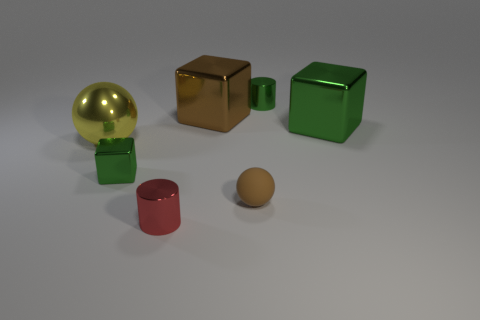Add 3 small green things. How many objects exist? 10 Subtract all spheres. How many objects are left? 5 Add 6 large green things. How many large green things are left? 7 Add 6 big green metal objects. How many big green metal objects exist? 7 Subtract 0 gray blocks. How many objects are left? 7 Subtract all small red objects. Subtract all red objects. How many objects are left? 5 